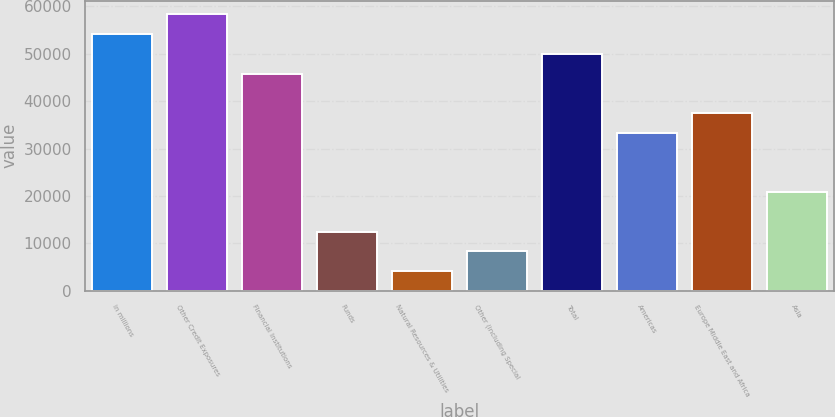Convert chart to OTSL. <chart><loc_0><loc_0><loc_500><loc_500><bar_chart><fcel>in millions<fcel>Other Credit Exposures<fcel>Financial Institutions<fcel>Funds<fcel>Natural Resources & Utilities<fcel>Other (including Special<fcel>Total<fcel>Americas<fcel>Europe Middle East and Africa<fcel>Asia<nl><fcel>54142.8<fcel>58307.4<fcel>45813.6<fcel>12496.8<fcel>4167.6<fcel>8332.2<fcel>49978.2<fcel>33319.8<fcel>37484.4<fcel>20826<nl></chart> 